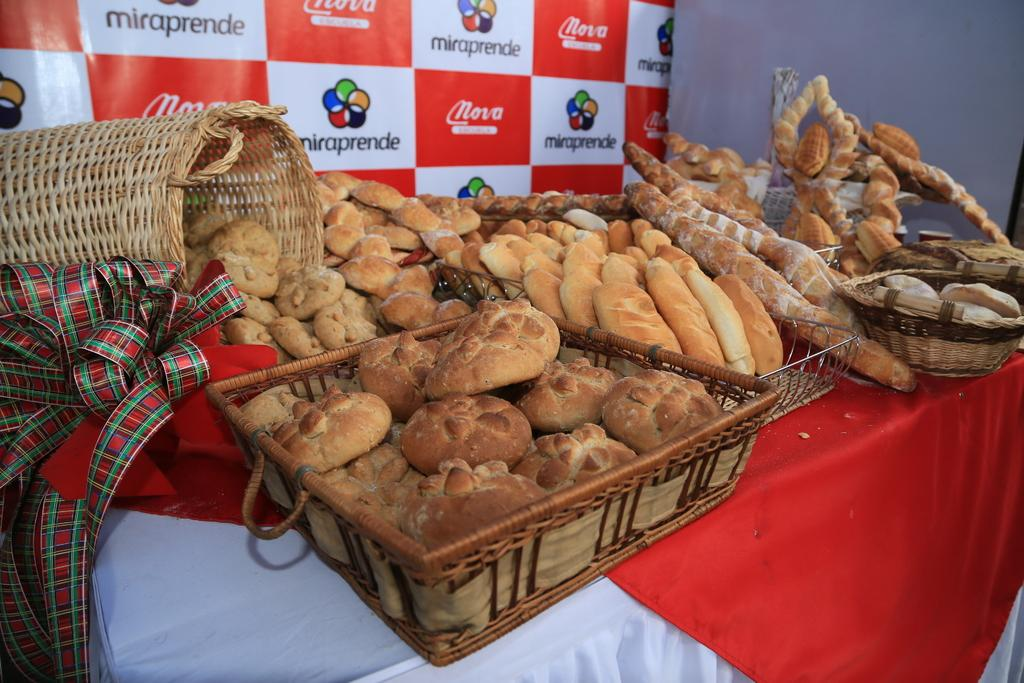What is located in the foreground of the picture? There is a table in the foreground of the picture. What can be found on the table? Food items, baskets, a cloth, and other objects are on the table. What is visible in the background of the picture? There is a banner and other objects visible in the background of the picture. How many thumbs can be seen on the body in the image? There is no body or thumb present in the image. What type of cellar is visible in the background of the image? There is no cellar present in the image; it features a table with various items and a banner in the background. 